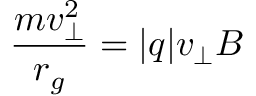Convert formula to latex. <formula><loc_0><loc_0><loc_500><loc_500>{ \frac { m v _ { \perp } ^ { 2 } } { r _ { g } } } = | q | v _ { \perp } B</formula> 